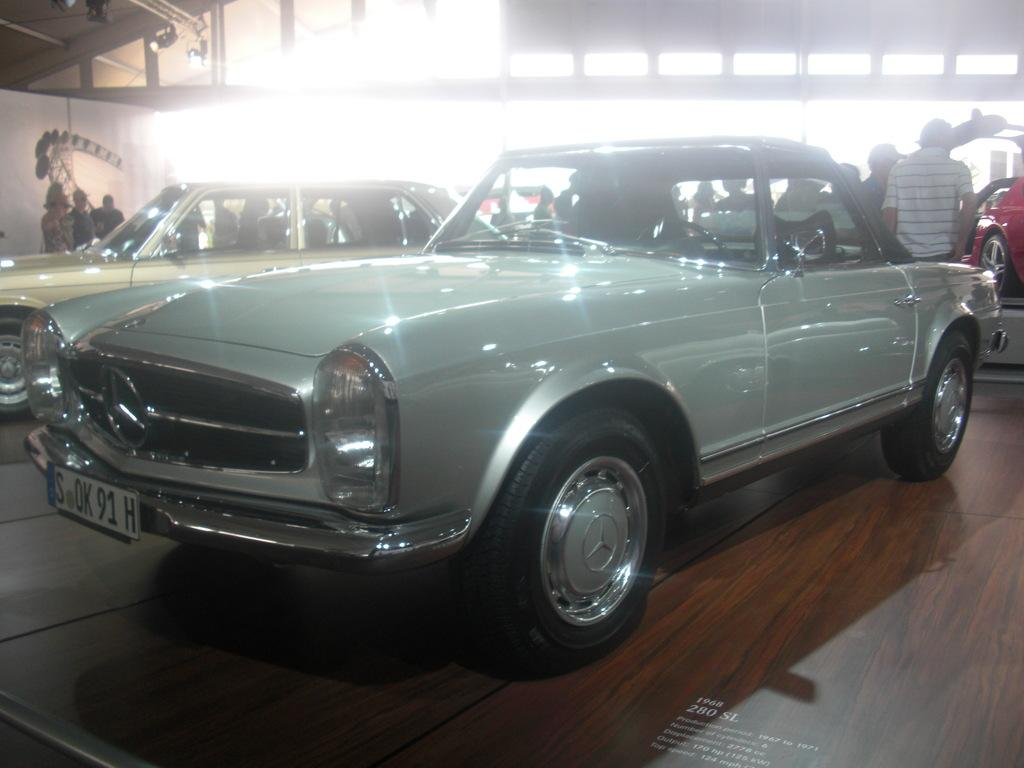What can be found inside the shed in the image? There are vehicles inside the shed in the image. What else can be seen near the vehicles? There are people with different color dresses near the vehicles. Can you describe the object to the left in the image? There is a white color object to the left in the image. What type of list can be seen hanging on the wall in the image? There is no list visible on the wall in the image. 